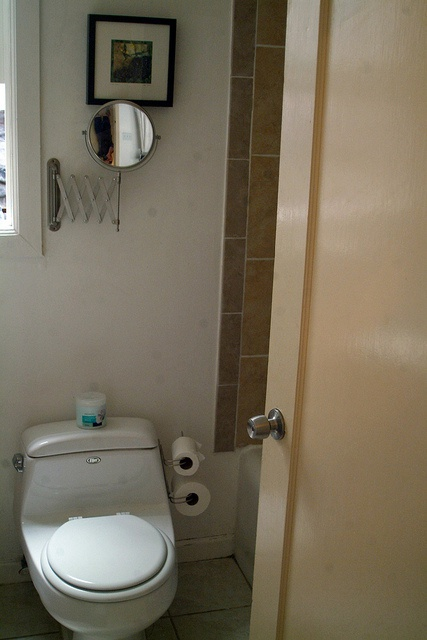Describe the objects in this image and their specific colors. I can see a toilet in darkgray, gray, lightgray, and darkgreen tones in this image. 